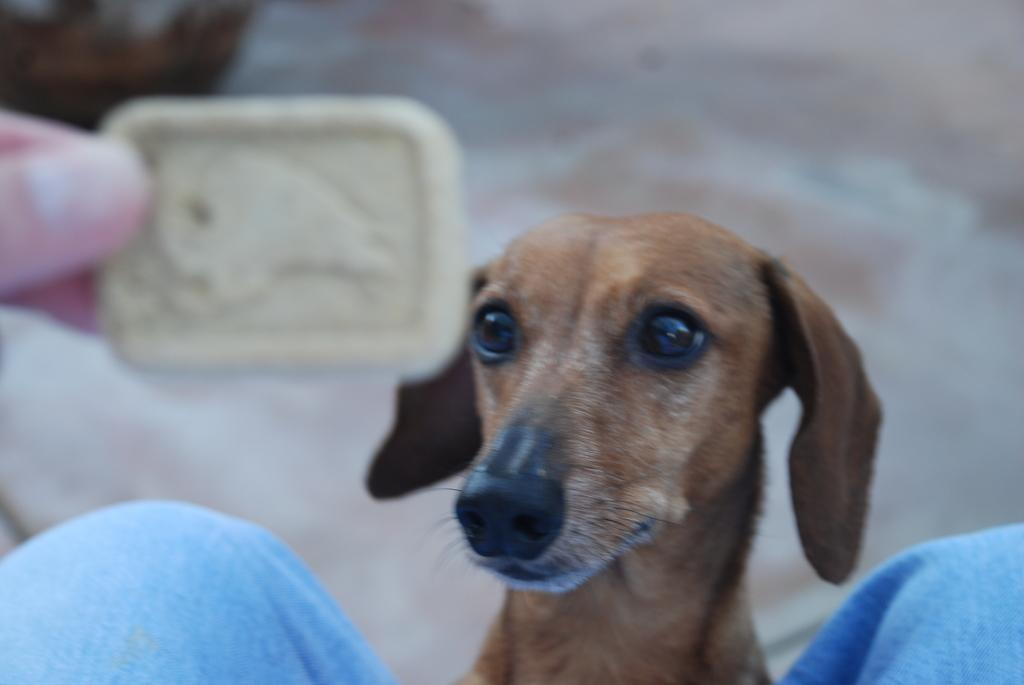What is the main subject in the middle of the image? There is a dog in the middle of the image. What is the person holding in the image? The person is holding a biscuit in the image. Where is the person located in the image? The person is on the left side of the image. What type of sugar can be seen growing in the image? There is no sugar or produce present in the image; it features a dog and a person holding a biscuit. How does the dog's behavior change when the person offers the biscuit? The provided facts do not mention the dog's behavior or the interaction between the dog and the person, so we cannot determine how the dog's behavior changes when the person offers the biscuit. 